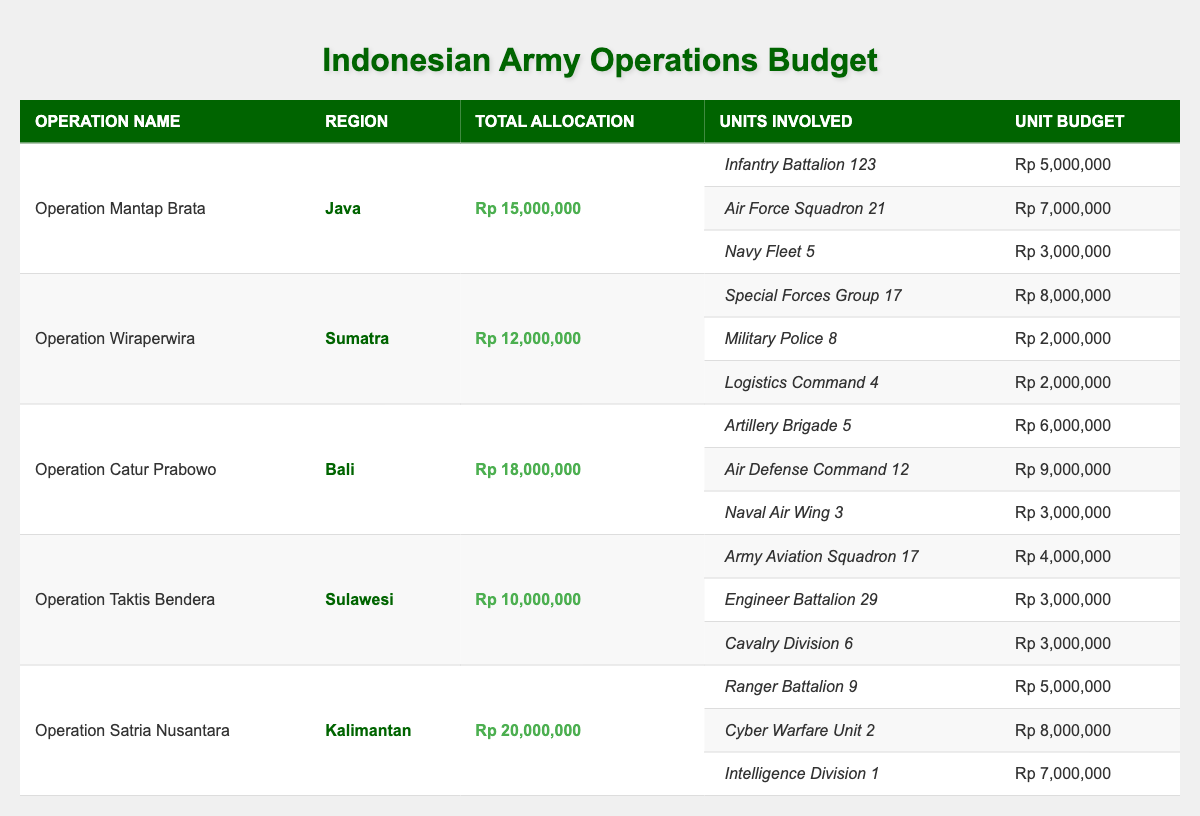What is the total budget allocation for Operation Catur Prabowo? From the table, the total allocation for Operation Catur Prabowo is listed as Rp 18,000,000.
Answer: Rp 18,000,000 Which unit had the highest allocated budget in Operation Wiraperwira? By examining the unit budgets under Operation Wiraperwira, the Special Forces Group 17 received Rp 8,000,000, which is the highest among the three units listed.
Answer: Special Forces Group 17 What is the total allocation for all operations combined? To find the total allocation, we sum all individual allocations: Rp 15,000,000 (Mantap Brata) + Rp 12,000,000 (Wiraperwira) + Rp 18,000,000 (Catur Prabowo) + Rp 10,000,000 (Taktis Bendera) + Rp 20,000,000 (Satria Nusantara) = Rp 85,000,000.
Answer: Rp 85,000,000 Is the total allocation for Operation Satria Nusantara greater than that of Operation Taktis Bendera? The total allocation for Satria Nusantara is Rp 20,000,000, and for Taktis Bendera it is Rp 10,000,000. Since 20,000,000 > 10,000,000, the statement is true.
Answer: Yes What is the average budget allocation per operation? First, we count the number of operations, which is 5. Next, we sum their total allocations (Rp 85,000,000) and divide by the number of operations: 85,000,000 / 5 = Rp 17,000,000.
Answer: Rp 17,000,000 Which region has the highest total budget allocation among all operations? By adding the total allocations for each region: Java (Rp 15,000,000), Sumatra (Rp 12,000,000), Bali (Rp 18,000,000), Sulawesi (Rp 10,000,000), and Kalimantan (Rp 20,000,000), we see that Kalimantan has the highest budget at Rp 20,000,000.
Answer: Kalimantan How much was the budget for the Navy Fleet 5 compared to the total budget of Operation Mantap Brata? The budget for Navy Fleet 5 is Rp 3,000,000. The total budget for Operation Mantap Brata is Rp 15,000,000. Comparing the two shows that Navy Fleet 5's budget is less than Mantap Brata's total.
Answer: Navy Fleet 5 is less than Mantap Brata's total What percentage of the total allocation for Operation Satria Nusantara was given to the Cyber Warfare Unit 2? The allocation for Cyber Warfare Unit 2 is Rp 8,000,000, while the total allocation for Satria Nusantara is Rp 20,000,000. To calculate the percentage: (8,000,000 / 20,000,000) * 100 = 40%.
Answer: 40% Which operation involved the least amount of total budget allocation? By checking the total allocations, Operation Taktis Bendera has the least amount at Rp 10,000,000 compared to others.
Answer: Operation Taktis Bendera Is the budget for Infantry Battalion 123 equal to the budget for Engineer Battalion 29? The budget for Infantry Battalion 123 is Rp 5,000,000, while for Engineer Battalion 29 it is Rp 3,000,000. Since they are not equal, the answer is no.
Answer: No 